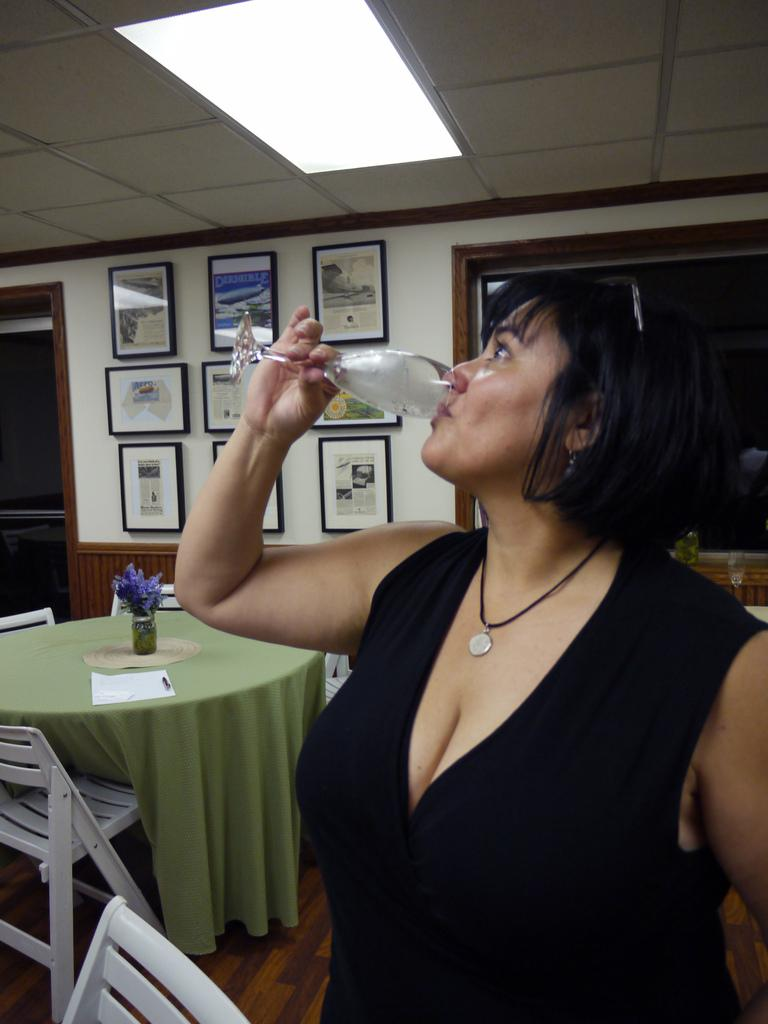Who is present in the image? There is a lady in the image. What is the lady holding in the image? The lady is holding a glass. What is the lady doing with the glass? The lady is drinking a drink. What can be seen on the wall in the image? There are frames attached to the wall. What type of furniture is present in the image? There are chairs in the image. What can be seen on the table in the image? There is a flower vase on a table. What architectural features are visible in the image? There are windows and a ceiling visible in the image. Reasoning: Let's think step by step by breaking down the image into its main components. We start by identifying the main subject, which is the lady. Then, we describe what she is doing and what she is holding. Next, we move on to the objects and features in the background, such as the frames, chairs, flower vase, windows, and ceiling. Each question is designed to elicit a specific detail about the image that is known from the provided facts. Absurd Question/Answer: What type of bulb is growing in the flower vase in the image? There is no bulb growing in the flower vase in the image; it contains flowers. How many birds are in the flock that is visible in the image? There are no birds or flocks present in the image. 